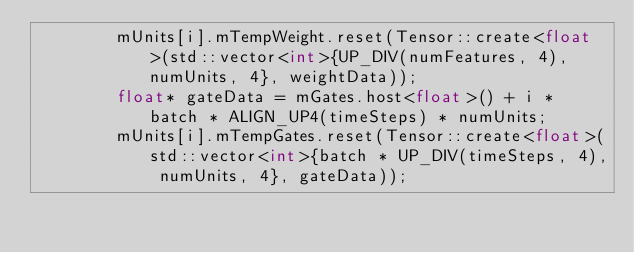Convert code to text. <code><loc_0><loc_0><loc_500><loc_500><_C++_>        mUnits[i].mTempWeight.reset(Tensor::create<float>(std::vector<int>{UP_DIV(numFeatures, 4), numUnits, 4}, weightData));
        float* gateData = mGates.host<float>() + i * batch * ALIGN_UP4(timeSteps) * numUnits;
        mUnits[i].mTempGates.reset(Tensor::create<float>(std::vector<int>{batch * UP_DIV(timeSteps, 4), numUnits, 4}, gateData));</code> 